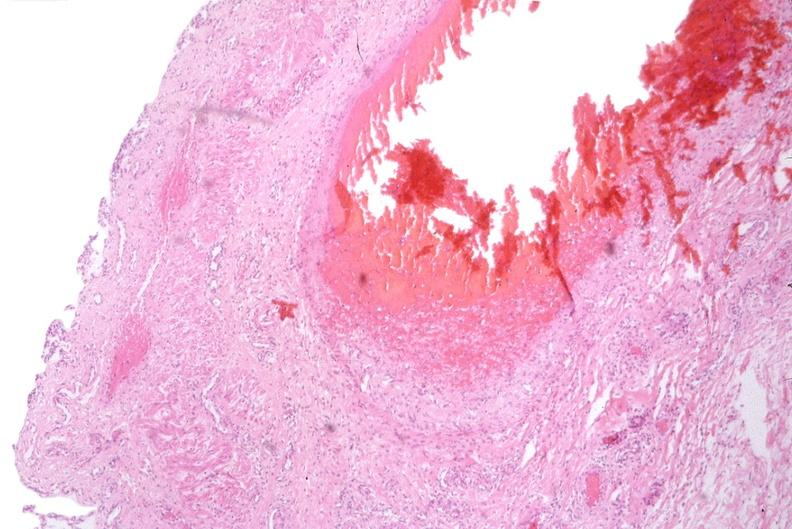where is this from?
Answer the question using a single word or phrase. Gastrointestinal system 